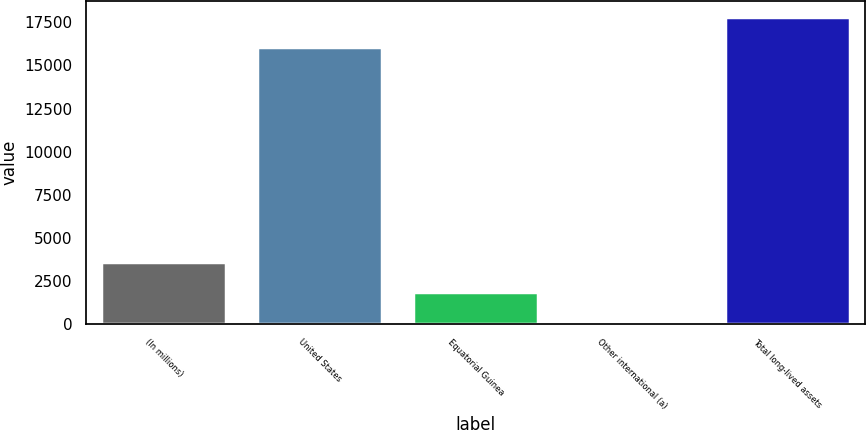Convert chart. <chart><loc_0><loc_0><loc_500><loc_500><bar_chart><fcel>(In millions)<fcel>United States<fcel>Equatorial Guinea<fcel>Other international (a)<fcel>Total long-lived assets<nl><fcel>3607.4<fcel>16094<fcel>1864.7<fcel>122<fcel>17836.7<nl></chart> 